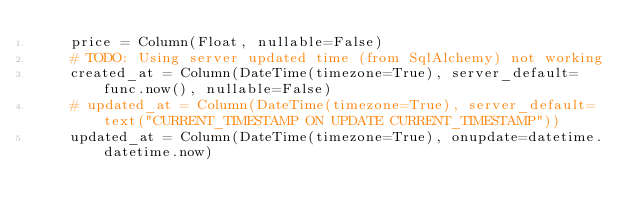Convert code to text. <code><loc_0><loc_0><loc_500><loc_500><_Python_>    price = Column(Float, nullable=False)
    # TODO: Using server updated time (from SqlAlchemy) not working
    created_at = Column(DateTime(timezone=True), server_default=func.now(), nullable=False)
    # updated_at = Column(DateTime(timezone=True), server_default=text("CURRENT_TIMESTAMP ON UPDATE CURRENT_TIMESTAMP"))
    updated_at = Column(DateTime(timezone=True), onupdate=datetime.datetime.now)</code> 